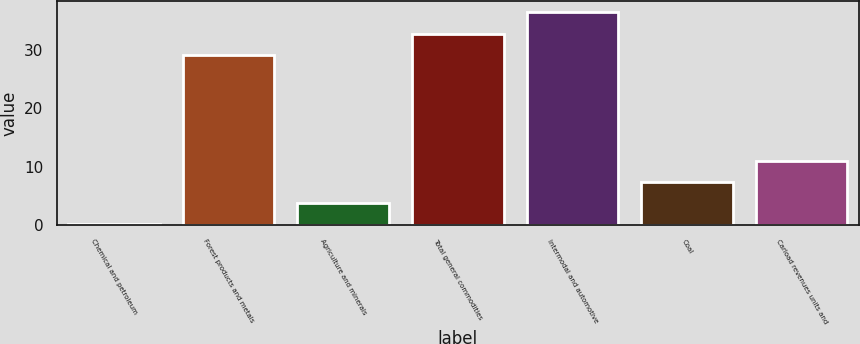Convert chart. <chart><loc_0><loc_0><loc_500><loc_500><bar_chart><fcel>Chemical and petroleum<fcel>Forest products and metals<fcel>Agriculture and minerals<fcel>Total general commodities<fcel>Intermodal and automotive<fcel>Coal<fcel>Carload revenues units and<nl><fcel>0.1<fcel>29.1<fcel>3.74<fcel>32.74<fcel>36.5<fcel>7.38<fcel>11.02<nl></chart> 